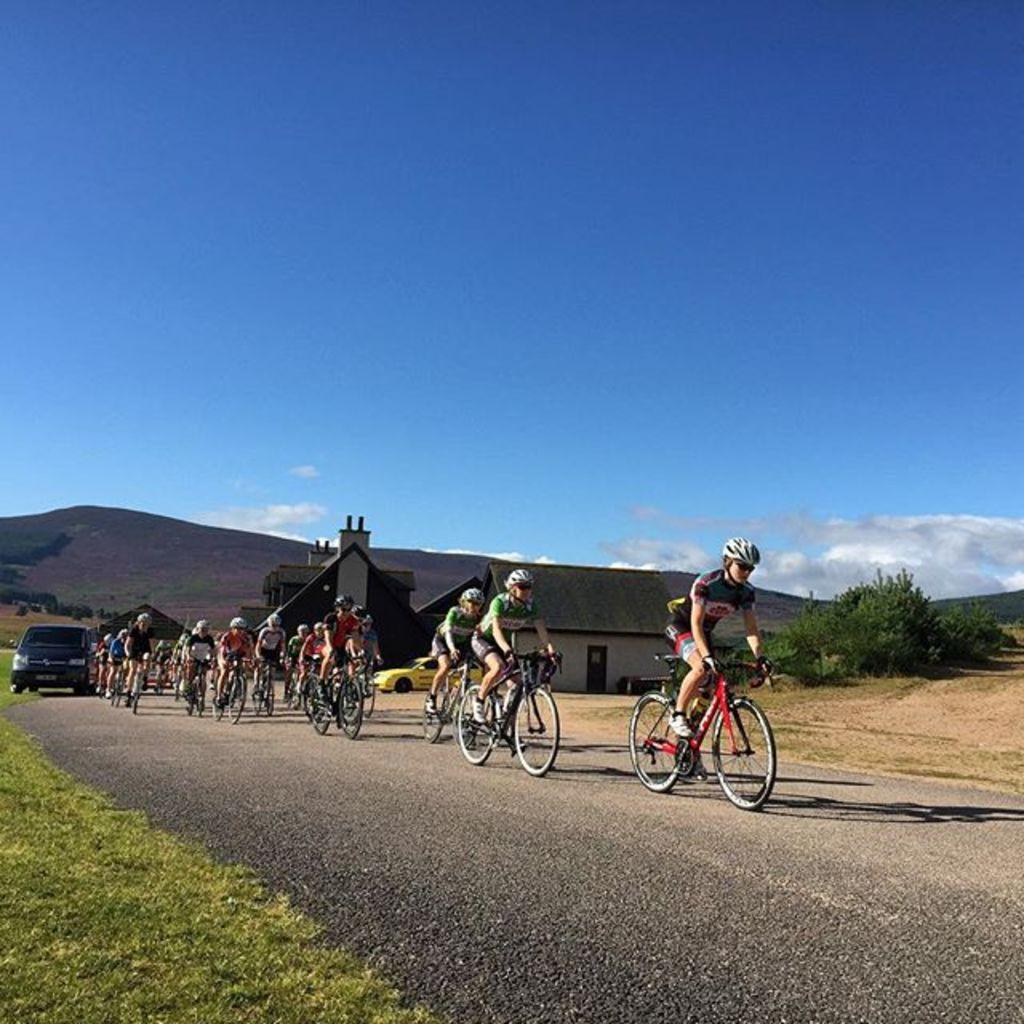How many people are in the image? There are many people in the image. What are the people doing in the image? The people are cycling. What can be seen in the background of the image? The background of the image is the sky. What type of tools does the carpenter have in the image? There is no carpenter present in the image, so there are no tools to describe. 